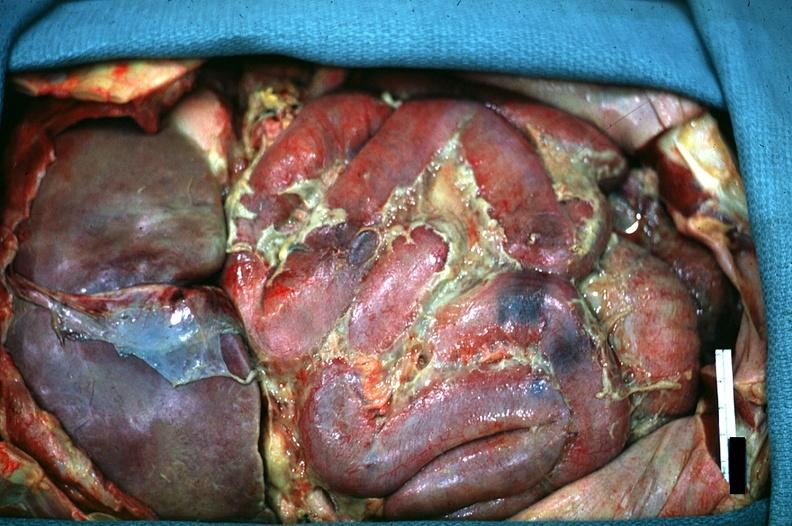does carcinomatosis show in situ of abdomen excellent fibrinopurulent peritonitis?
Answer the question using a single word or phrase. No 